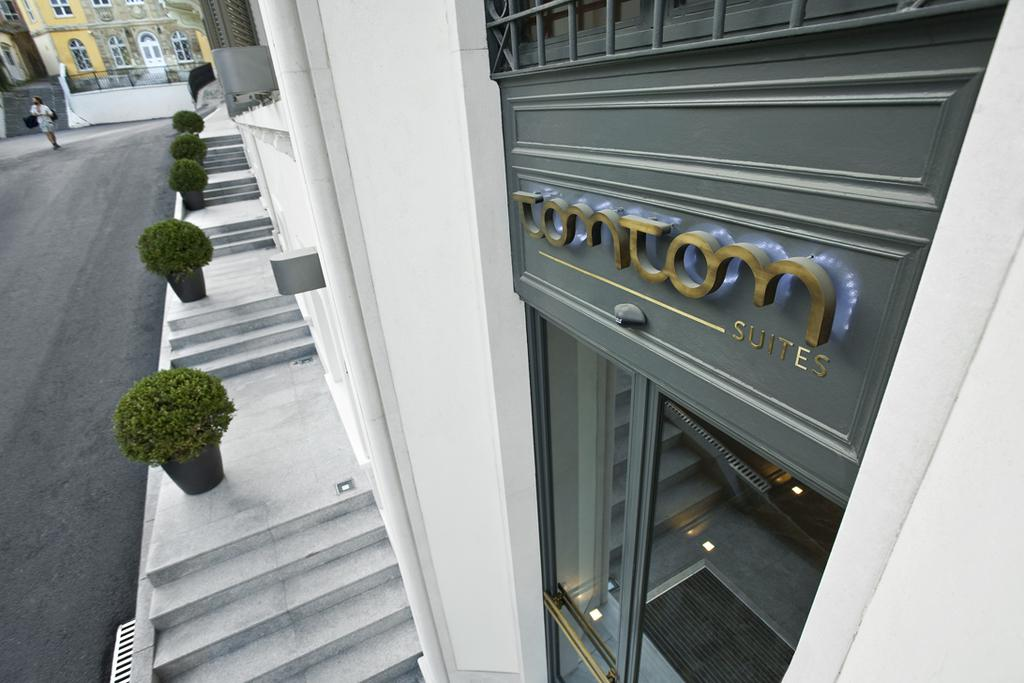<image>
Provide a brief description of the given image. The front image of a hotel called, Tom Tom Suites. 